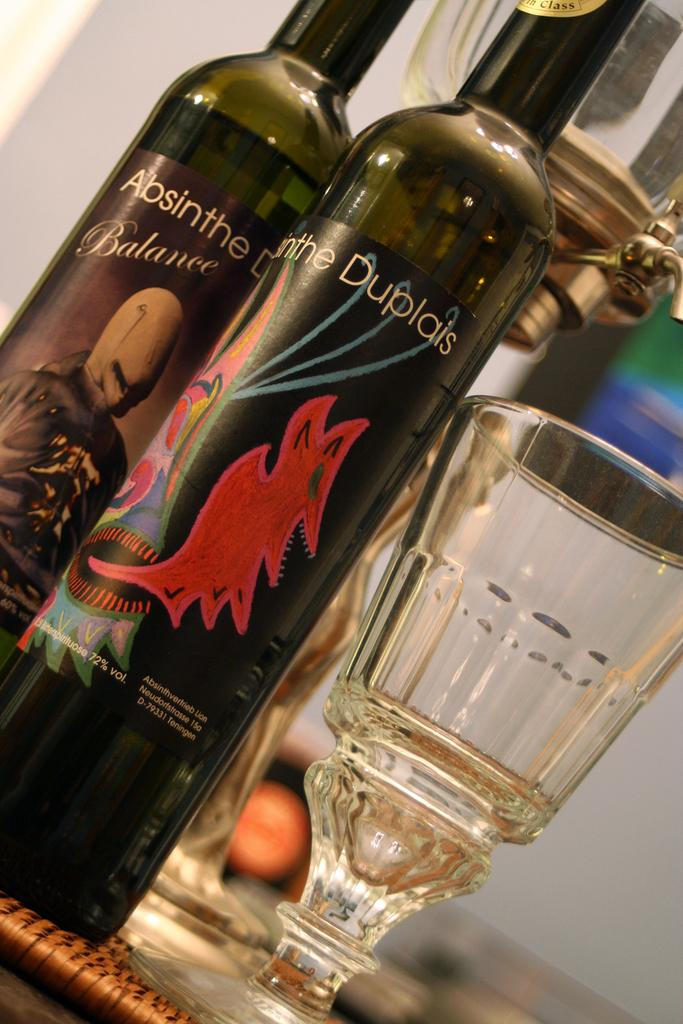What is the main object in the image? There is a table in the image. What items are placed on the table? Two wine bottles and two glasses are placed on the table. Can you describe the background of the image? The background of the image is blurred. What time does the clock show in the image? There is no clock present in the image. How does the beginner handle the wine bottles in the image? There is no indication of a beginner or any interaction with the wine bottles in the image. 